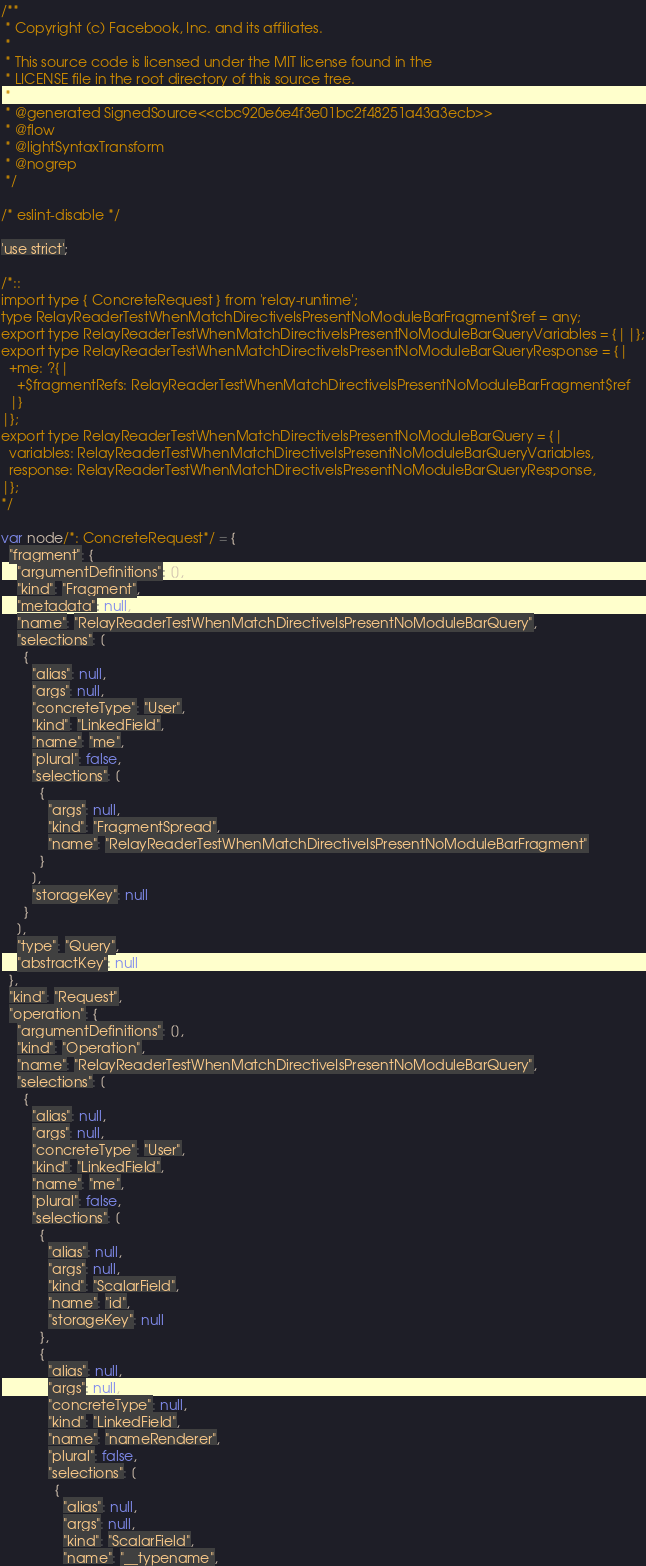Convert code to text. <code><loc_0><loc_0><loc_500><loc_500><_JavaScript_>/**
 * Copyright (c) Facebook, Inc. and its affiliates.
 * 
 * This source code is licensed under the MIT license found in the
 * LICENSE file in the root directory of this source tree.
 *
 * @generated SignedSource<<cbc920e6e4f3e01bc2f48251a43a3ecb>>
 * @flow
 * @lightSyntaxTransform
 * @nogrep
 */

/* eslint-disable */

'use strict';

/*::
import type { ConcreteRequest } from 'relay-runtime';
type RelayReaderTestWhenMatchDirectiveIsPresentNoModuleBarFragment$ref = any;
export type RelayReaderTestWhenMatchDirectiveIsPresentNoModuleBarQueryVariables = {||};
export type RelayReaderTestWhenMatchDirectiveIsPresentNoModuleBarQueryResponse = {|
  +me: ?{|
    +$fragmentRefs: RelayReaderTestWhenMatchDirectiveIsPresentNoModuleBarFragment$ref
  |}
|};
export type RelayReaderTestWhenMatchDirectiveIsPresentNoModuleBarQuery = {|
  variables: RelayReaderTestWhenMatchDirectiveIsPresentNoModuleBarQueryVariables,
  response: RelayReaderTestWhenMatchDirectiveIsPresentNoModuleBarQueryResponse,
|};
*/

var node/*: ConcreteRequest*/ = {
  "fragment": {
    "argumentDefinitions": [],
    "kind": "Fragment",
    "metadata": null,
    "name": "RelayReaderTestWhenMatchDirectiveIsPresentNoModuleBarQuery",
    "selections": [
      {
        "alias": null,
        "args": null,
        "concreteType": "User",
        "kind": "LinkedField",
        "name": "me",
        "plural": false,
        "selections": [
          {
            "args": null,
            "kind": "FragmentSpread",
            "name": "RelayReaderTestWhenMatchDirectiveIsPresentNoModuleBarFragment"
          }
        ],
        "storageKey": null
      }
    ],
    "type": "Query",
    "abstractKey": null
  },
  "kind": "Request",
  "operation": {
    "argumentDefinitions": [],
    "kind": "Operation",
    "name": "RelayReaderTestWhenMatchDirectiveIsPresentNoModuleBarQuery",
    "selections": [
      {
        "alias": null,
        "args": null,
        "concreteType": "User",
        "kind": "LinkedField",
        "name": "me",
        "plural": false,
        "selections": [
          {
            "alias": null,
            "args": null,
            "kind": "ScalarField",
            "name": "id",
            "storageKey": null
          },
          {
            "alias": null,
            "args": null,
            "concreteType": null,
            "kind": "LinkedField",
            "name": "nameRenderer",
            "plural": false,
            "selections": [
              {
                "alias": null,
                "args": null,
                "kind": "ScalarField",
                "name": "__typename",</code> 